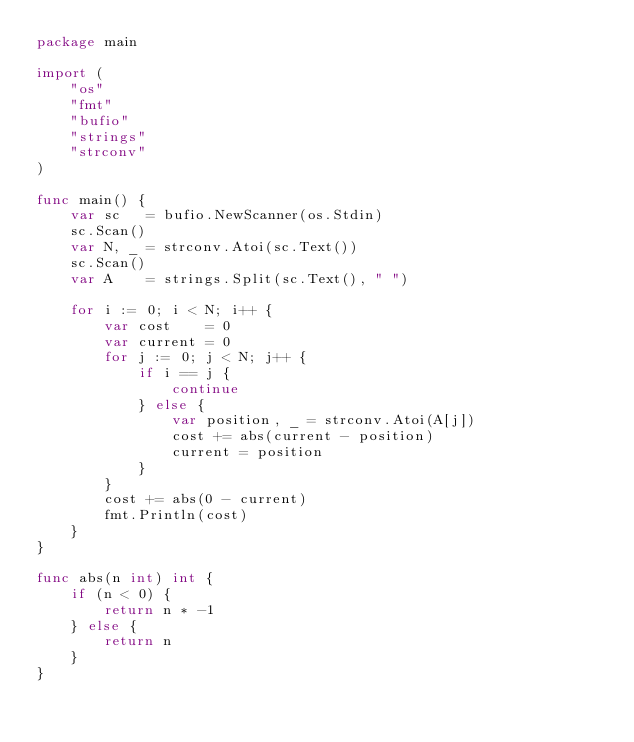<code> <loc_0><loc_0><loc_500><loc_500><_Go_>package main

import (
	"os"
	"fmt"
	"bufio"
	"strings"
	"strconv"
)

func main() {
	var sc   = bufio.NewScanner(os.Stdin)
	sc.Scan()
	var N, _ = strconv.Atoi(sc.Text())
	sc.Scan()
	var A    = strings.Split(sc.Text(), " ")

	for i := 0; i < N; i++ {
		var cost    = 0
		var current = 0
		for j := 0; j < N; j++ {
			if i == j {
				continue
			} else {
				var position, _ = strconv.Atoi(A[j])
				cost += abs(current - position)
				current = position
			}
		}
		cost += abs(0 - current)
		fmt.Println(cost)
	}
}

func abs(n int) int {
	if (n < 0) {
		return n * -1
	} else {
		return n
	}
}</code> 